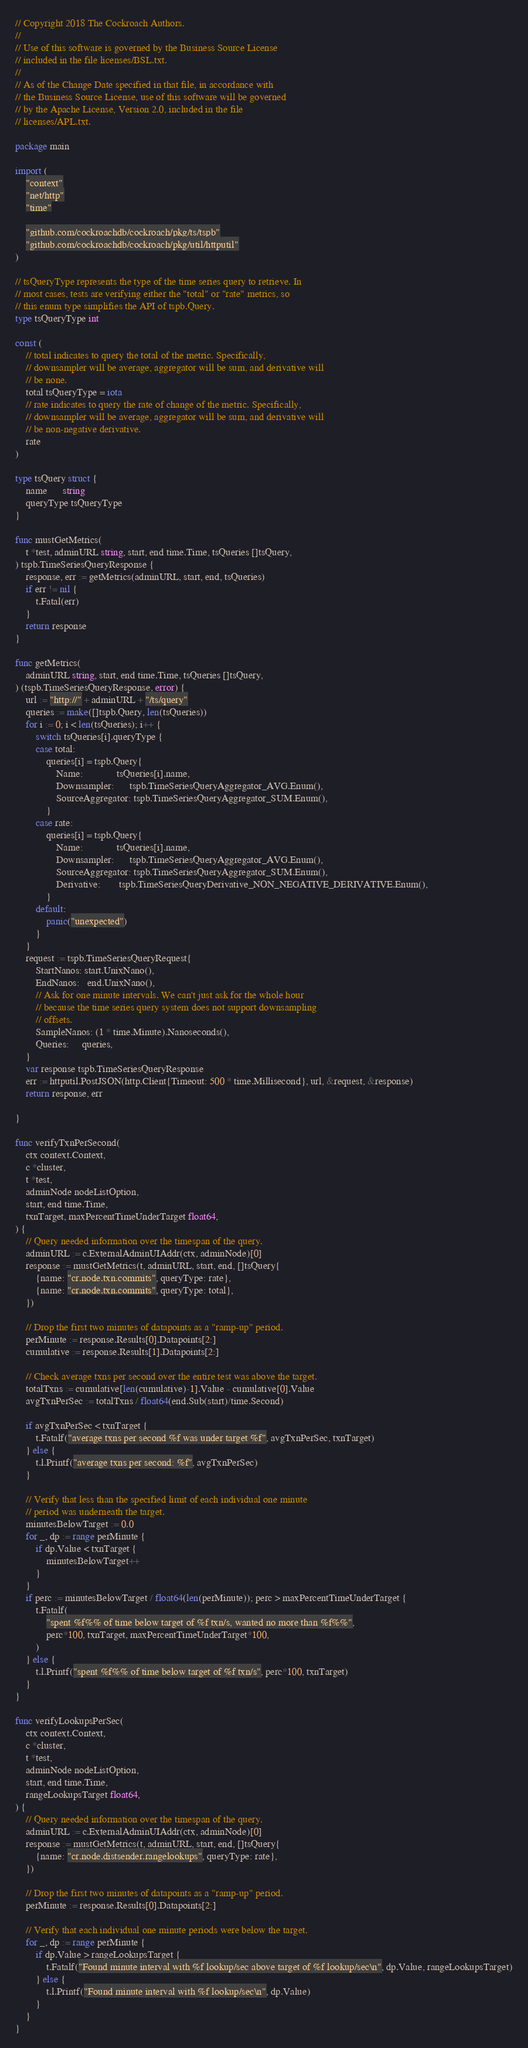Convert code to text. <code><loc_0><loc_0><loc_500><loc_500><_Go_>// Copyright 2018 The Cockroach Authors.
//
// Use of this software is governed by the Business Source License
// included in the file licenses/BSL.txt.
//
// As of the Change Date specified in that file, in accordance with
// the Business Source License, use of this software will be governed
// by the Apache License, Version 2.0, included in the file
// licenses/APL.txt.

package main

import (
	"context"
	"net/http"
	"time"

	"github.com/cockroachdb/cockroach/pkg/ts/tspb"
	"github.com/cockroachdb/cockroach/pkg/util/httputil"
)

// tsQueryType represents the type of the time series query to retrieve. In
// most cases, tests are verifying either the "total" or "rate" metrics, so
// this enum type simplifies the API of tspb.Query.
type tsQueryType int

const (
	// total indicates to query the total of the metric. Specifically,
	// downsampler will be average, aggregator will be sum, and derivative will
	// be none.
	total tsQueryType = iota
	// rate indicates to query the rate of change of the metric. Specifically,
	// downsampler will be average, aggregator will be sum, and derivative will
	// be non-negative derivative.
	rate
)

type tsQuery struct {
	name      string
	queryType tsQueryType
}

func mustGetMetrics(
	t *test, adminURL string, start, end time.Time, tsQueries []tsQuery,
) tspb.TimeSeriesQueryResponse {
	response, err := getMetrics(adminURL, start, end, tsQueries)
	if err != nil {
		t.Fatal(err)
	}
	return response
}

func getMetrics(
	adminURL string, start, end time.Time, tsQueries []tsQuery,
) (tspb.TimeSeriesQueryResponse, error) {
	url := "http://" + adminURL + "/ts/query"
	queries := make([]tspb.Query, len(tsQueries))
	for i := 0; i < len(tsQueries); i++ {
		switch tsQueries[i].queryType {
		case total:
			queries[i] = tspb.Query{
				Name:             tsQueries[i].name,
				Downsampler:      tspb.TimeSeriesQueryAggregator_AVG.Enum(),
				SourceAggregator: tspb.TimeSeriesQueryAggregator_SUM.Enum(),
			}
		case rate:
			queries[i] = tspb.Query{
				Name:             tsQueries[i].name,
				Downsampler:      tspb.TimeSeriesQueryAggregator_AVG.Enum(),
				SourceAggregator: tspb.TimeSeriesQueryAggregator_SUM.Enum(),
				Derivative:       tspb.TimeSeriesQueryDerivative_NON_NEGATIVE_DERIVATIVE.Enum(),
			}
		default:
			panic("unexpected")
		}
	}
	request := tspb.TimeSeriesQueryRequest{
		StartNanos: start.UnixNano(),
		EndNanos:   end.UnixNano(),
		// Ask for one minute intervals. We can't just ask for the whole hour
		// because the time series query system does not support downsampling
		// offsets.
		SampleNanos: (1 * time.Minute).Nanoseconds(),
		Queries:     queries,
	}
	var response tspb.TimeSeriesQueryResponse
	err := httputil.PostJSON(http.Client{Timeout: 500 * time.Millisecond}, url, &request, &response)
	return response, err

}

func verifyTxnPerSecond(
	ctx context.Context,
	c *cluster,
	t *test,
	adminNode nodeListOption,
	start, end time.Time,
	txnTarget, maxPercentTimeUnderTarget float64,
) {
	// Query needed information over the timespan of the query.
	adminURL := c.ExternalAdminUIAddr(ctx, adminNode)[0]
	response := mustGetMetrics(t, adminURL, start, end, []tsQuery{
		{name: "cr.node.txn.commits", queryType: rate},
		{name: "cr.node.txn.commits", queryType: total},
	})

	// Drop the first two minutes of datapoints as a "ramp-up" period.
	perMinute := response.Results[0].Datapoints[2:]
	cumulative := response.Results[1].Datapoints[2:]

	// Check average txns per second over the entire test was above the target.
	totalTxns := cumulative[len(cumulative)-1].Value - cumulative[0].Value
	avgTxnPerSec := totalTxns / float64(end.Sub(start)/time.Second)

	if avgTxnPerSec < txnTarget {
		t.Fatalf("average txns per second %f was under target %f", avgTxnPerSec, txnTarget)
	} else {
		t.l.Printf("average txns per second: %f", avgTxnPerSec)
	}

	// Verify that less than the specified limit of each individual one minute
	// period was underneath the target.
	minutesBelowTarget := 0.0
	for _, dp := range perMinute {
		if dp.Value < txnTarget {
			minutesBelowTarget++
		}
	}
	if perc := minutesBelowTarget / float64(len(perMinute)); perc > maxPercentTimeUnderTarget {
		t.Fatalf(
			"spent %f%% of time below target of %f txn/s, wanted no more than %f%%",
			perc*100, txnTarget, maxPercentTimeUnderTarget*100,
		)
	} else {
		t.l.Printf("spent %f%% of time below target of %f txn/s", perc*100, txnTarget)
	}
}

func verifyLookupsPerSec(
	ctx context.Context,
	c *cluster,
	t *test,
	adminNode nodeListOption,
	start, end time.Time,
	rangeLookupsTarget float64,
) {
	// Query needed information over the timespan of the query.
	adminURL := c.ExternalAdminUIAddr(ctx, adminNode)[0]
	response := mustGetMetrics(t, adminURL, start, end, []tsQuery{
		{name: "cr.node.distsender.rangelookups", queryType: rate},
	})

	// Drop the first two minutes of datapoints as a "ramp-up" period.
	perMinute := response.Results[0].Datapoints[2:]

	// Verify that each individual one minute periods were below the target.
	for _, dp := range perMinute {
		if dp.Value > rangeLookupsTarget {
			t.Fatalf("Found minute interval with %f lookup/sec above target of %f lookup/sec\n", dp.Value, rangeLookupsTarget)
		} else {
			t.l.Printf("Found minute interval with %f lookup/sec\n", dp.Value)
		}
	}
}
</code> 